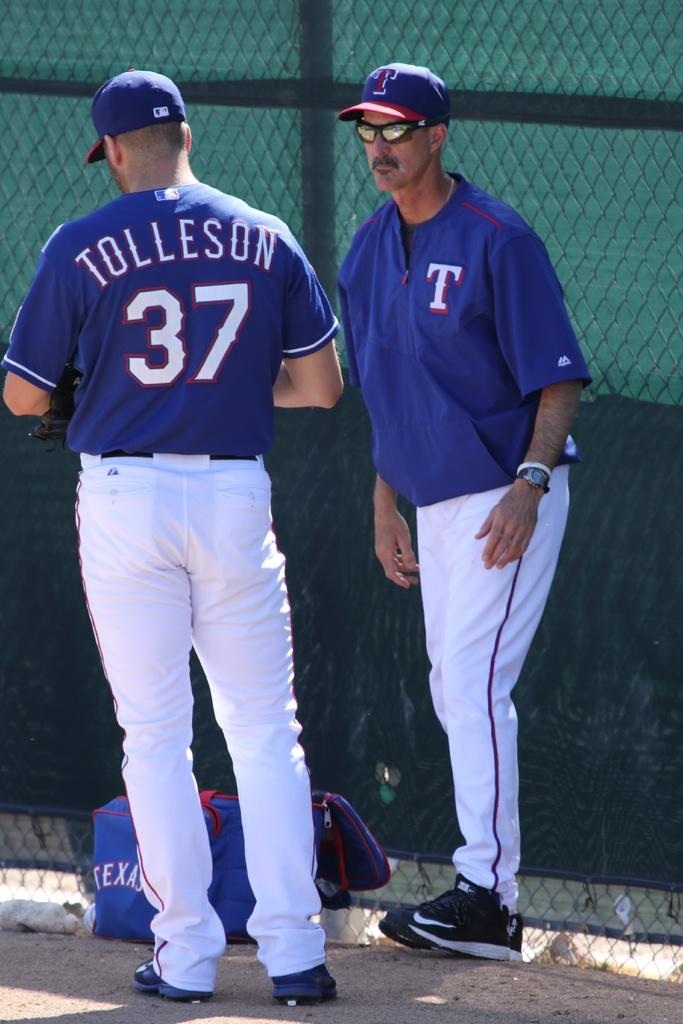What is the player's last name who is facing away from the camera?
Keep it short and to the point. Tolleson. What number is on his shirt?>?
Offer a terse response. 37. 